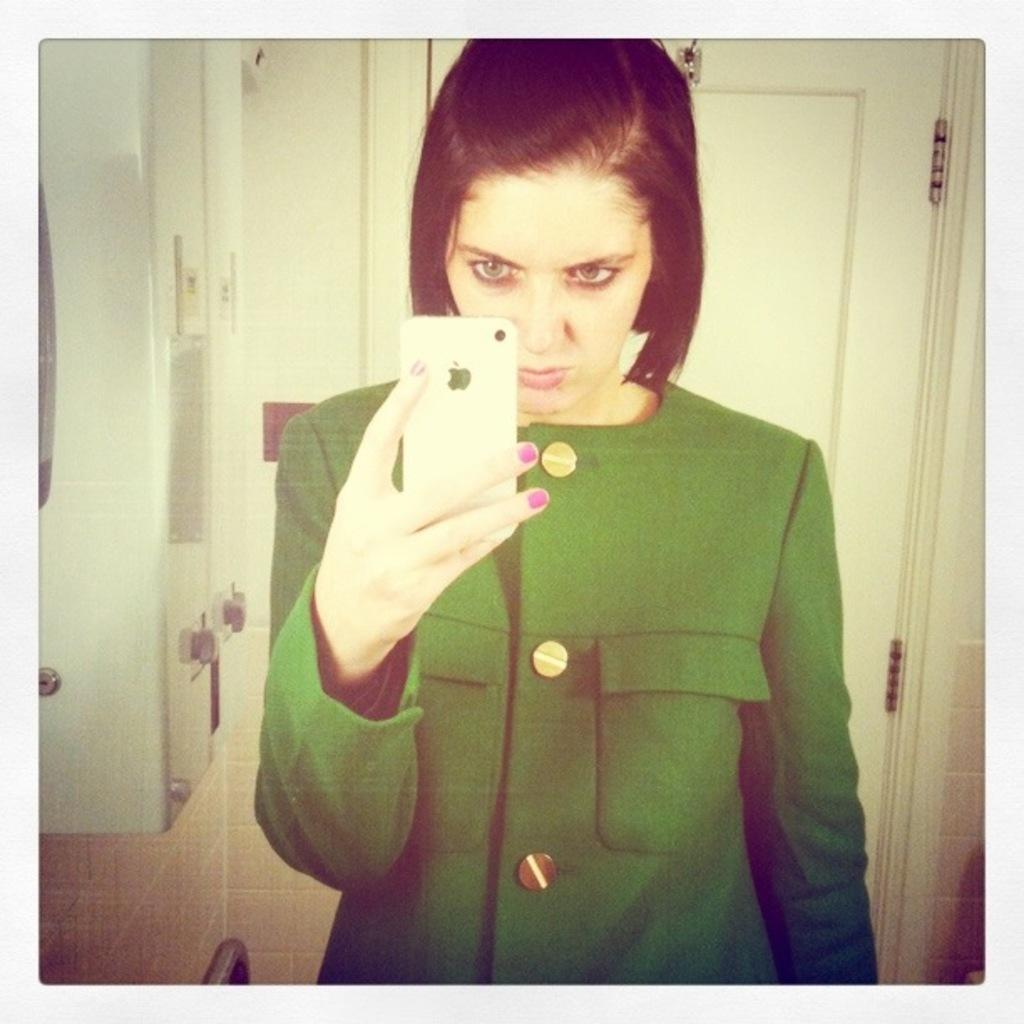Who is present in the image? There is a woman in the image. What is the woman holding in the image? The woman is holding an iPhone. What can be seen in the background of the image? There is a door in the background of the image. What color is the dress the woman is wearing? The woman is wearing a green color dress. What type of berry is the woman eating in the image? There is no berry present in the image, and the woman is not eating anything. 